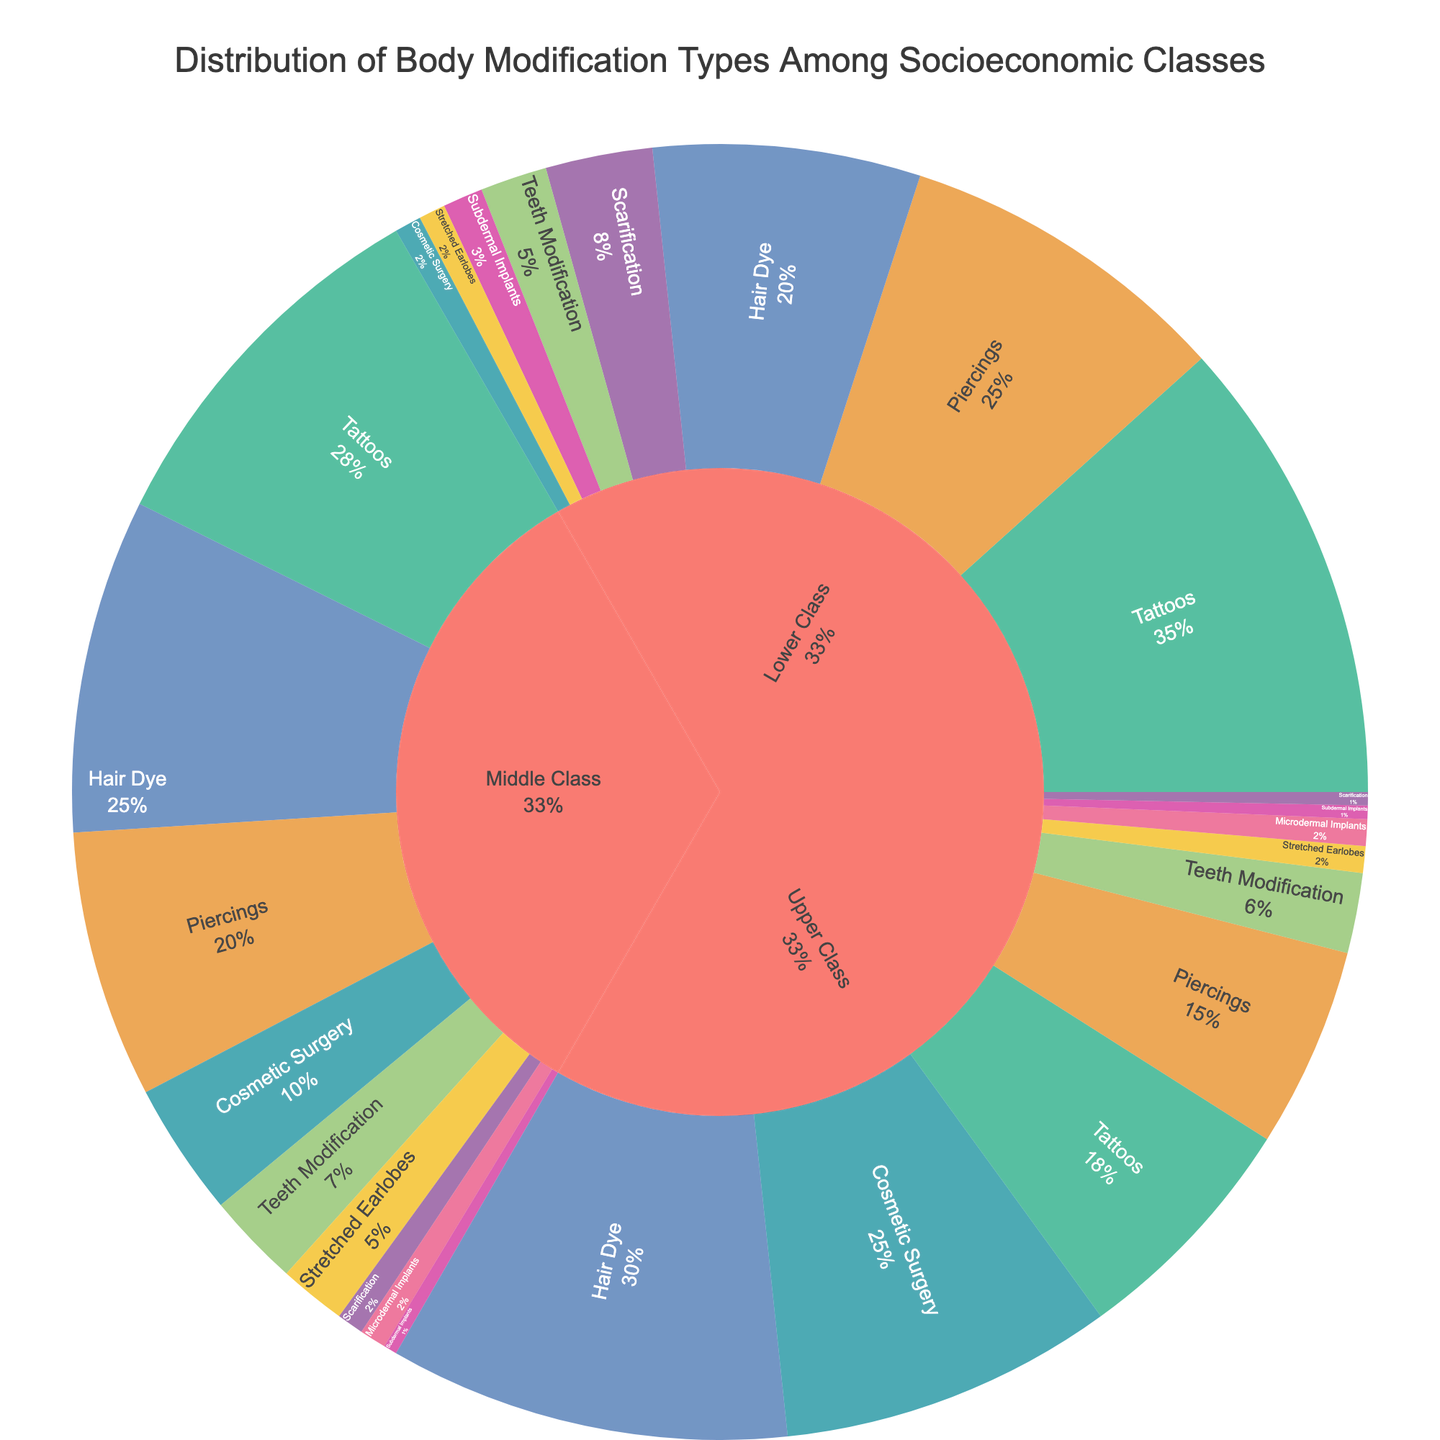Which socioeconomic class has the highest percentage of tattoos? The pie chart splits the body modification types by class and shows the percentage. By looking at the section representing tattoos, the biggest segment is for the Lower Class.
Answer: Lower Class Which body modification type has the largest percentage difference between the Lower Class and Upper Class? To find the largest percentage difference, we need to calculate the difference for each type and determine which is the largest. For tattoos, it's 35 - 18 = 17. For piercings, it's 25 - 15 = 10. Continuing this for all types, tattoos have the largest difference of 17%.
Answer: Tattoos How many total body modification types are there in the Upper Class? The total count of different body modification types for the Upper Class can be obtained by counting the different segments within the Upper Class section. There are 9 types in the Upper Class: Tattoos, Piercings, Scarification, Hair Dye, Cosmetic Surgery, Teeth Modification, Subdermal Implants, Stretched Earlobes, and Microdermal Implants.
Answer: 9 Which class has the highest percentage of Hair Dye modifications and what is its percentage? By looking at the segments representing Hair Dye for each class, the largest segment corresponds to the Upper Class with 30%.
Answer: Upper Class, 30% Compare the percentage of piercings in the Middle Class to the percentage of stretched earlobes in the same class. Which is higher and by how much? To compare, check the pie chart segments for piercings (20%) and stretched earlobes (5%) in the Middle Class. The piercings have a percentage larger by 20 - 5 = 15%.
Answer: Piercings are higher by 15% What is the total percentage of cosmetic surgery recorded across all socioeconomic classes? Summing up the percentages of cosmetic surgery for each class: 2 (Lower), 10 (Middle), and 25 (Upper) gives 2 + 10 + 25 = 37%.
Answer: 37% Is the percentage of subdermal implants in the Lower Class greater than the sum percentage of subdermal implants in the Middle and Upper Classes? The percentage of subdermal implants in the Lower Class is 3%. The combined percentage for the Middle (1%) and Upper (1%) classes is 1 + 1 = 2%. So, 3% > 2%.
Answer: Yes Which body modification types have equal percentages in the Upper Class, and what are those percentages? By visually inspecting segments, Scarification, Subdermal Implants, and Stretched Earlobes each have 1%, and Microdermal Implants 2%.
Answer: Subdermal Implants and Stretched Earlobes each have 1%, and Microdermal Implants have 2% What's the total percentage for Hair Dye and Cosmetic Surgery in the Upper Class? Sum the percentages of Hair Dye (30%) and Cosmetic Surgery (25%) giving 30 + 25 = 55%.
Answer: 55% What is the smallest percentage of body modification types in the Lower Class and what type is it? By examining the Lower Class section, the smallest percentage is 0% for Microdermal Implants.
Answer: Microdermal Implants, 0% 